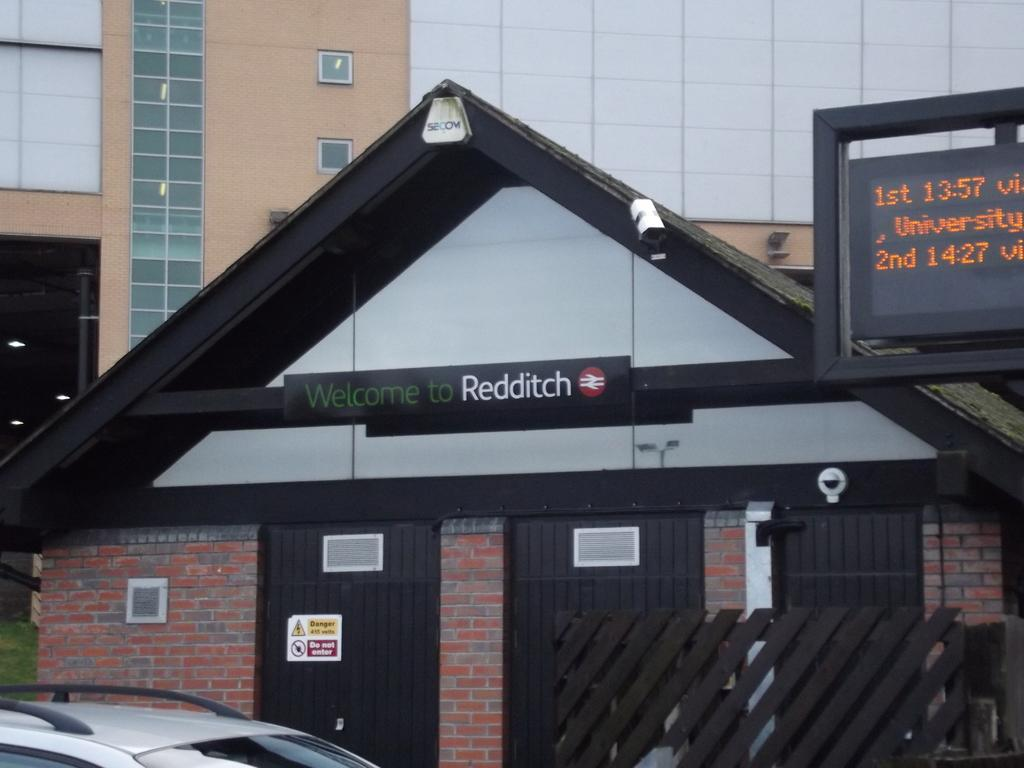What type of structure can be seen in the background of the image? There is a big building in the back of the image. What is located on the left side of the image? There is a vehicle on the left side of the image. What can be found on the right side of the image? There is a display board on the right side of the image. Are there any cobwebs visible on the display board in the image? There is no mention of cobwebs in the provided facts, and therefore we cannot determine if any are present in the image. How many chairs are visible in the image? There is no mention of chairs in the provided facts, and therefore we cannot determine if any are present in the image. 